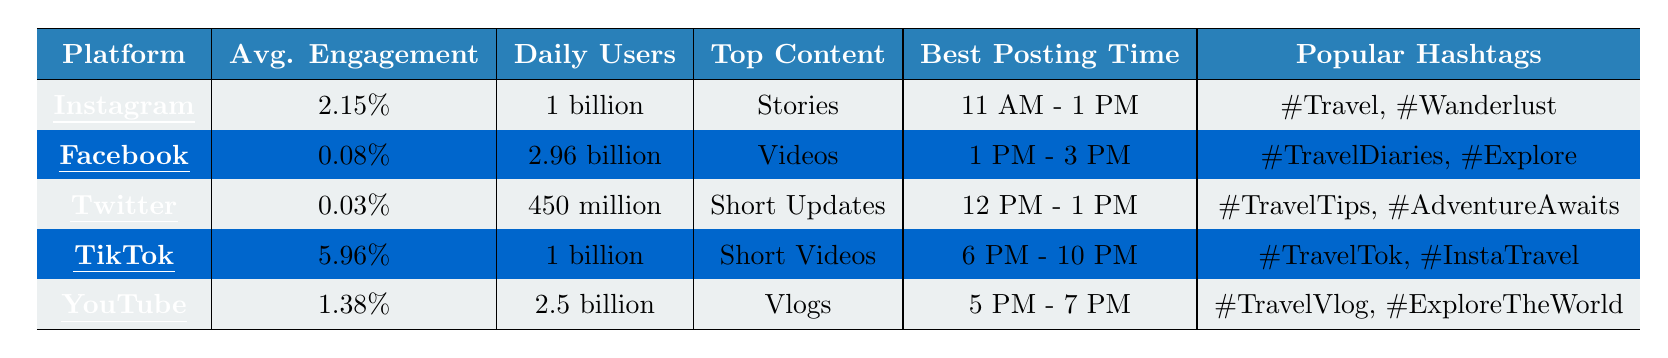What is the average engagement rate for TikTok? The table shows the average engagement rate for TikTok as 5.96%.
Answer: 5.96% How many daily active users does Instagram have? The table indicates that Instagram has 1 billion daily active users.
Answer: 1 billion Which platform has the highest average engagement rate? Checking the average engagement rates listed, TikTok has the highest rate at 5.96%.
Answer: TikTok What time is the best to post on YouTube? The table lists that the best posting time for YouTube is between 5 PM and 7 PM.
Answer: 5 PM - 7 PM Which platform's top content type is "Stories"? According to the table, Instagram's top content type is "Stories".
Answer: Instagram What is the average engagement rate across all platforms? To calculate, we sum the engagement rates: (2.15% + 0.08% + 0.03% + 5.96% + 1.38%) = 9.60%. Then, divide by the number of platforms (5): 9.60% / 5 = 1.92%.
Answer: 1.92% Is the average engagement rate for Facebook higher than that of Twitter? The average engagement rate for Facebook (0.08%) is compared to Twitter (0.03%). Since 0.08% is greater than 0.03%, the answer is yes.
Answer: Yes Which platforms share the same daily active users count of 1 billion? Both TikTok and Instagram have the same daily active users count of 1 billion, as indicated in the table.
Answer: TikTok and Instagram If you were to use the top hashtags listed for Instagram, which ones would you use? The table shows the popular hashtags for Instagram as #Travel, #Wanderlust, and #Adventure.
Answer: #Travel, #Wanderlust, #Adventure How many more daily active users does Facebook have than Twitter? Facebook has 2.96 billion daily active users while Twitter has 450 million. To find the difference, convert both to millions for easy calculation: 2960 million (Facebook) - 450 million (Twitter) = 2510 million.
Answer: 2510 million What is the top content type for Twitter? Referring to the table, Twitter's top content type is "Short Updates".
Answer: Short Updates Which platform has the least daily active users? The table presents that Twitter has the least daily active users at 450 million.
Answer: Twitter 